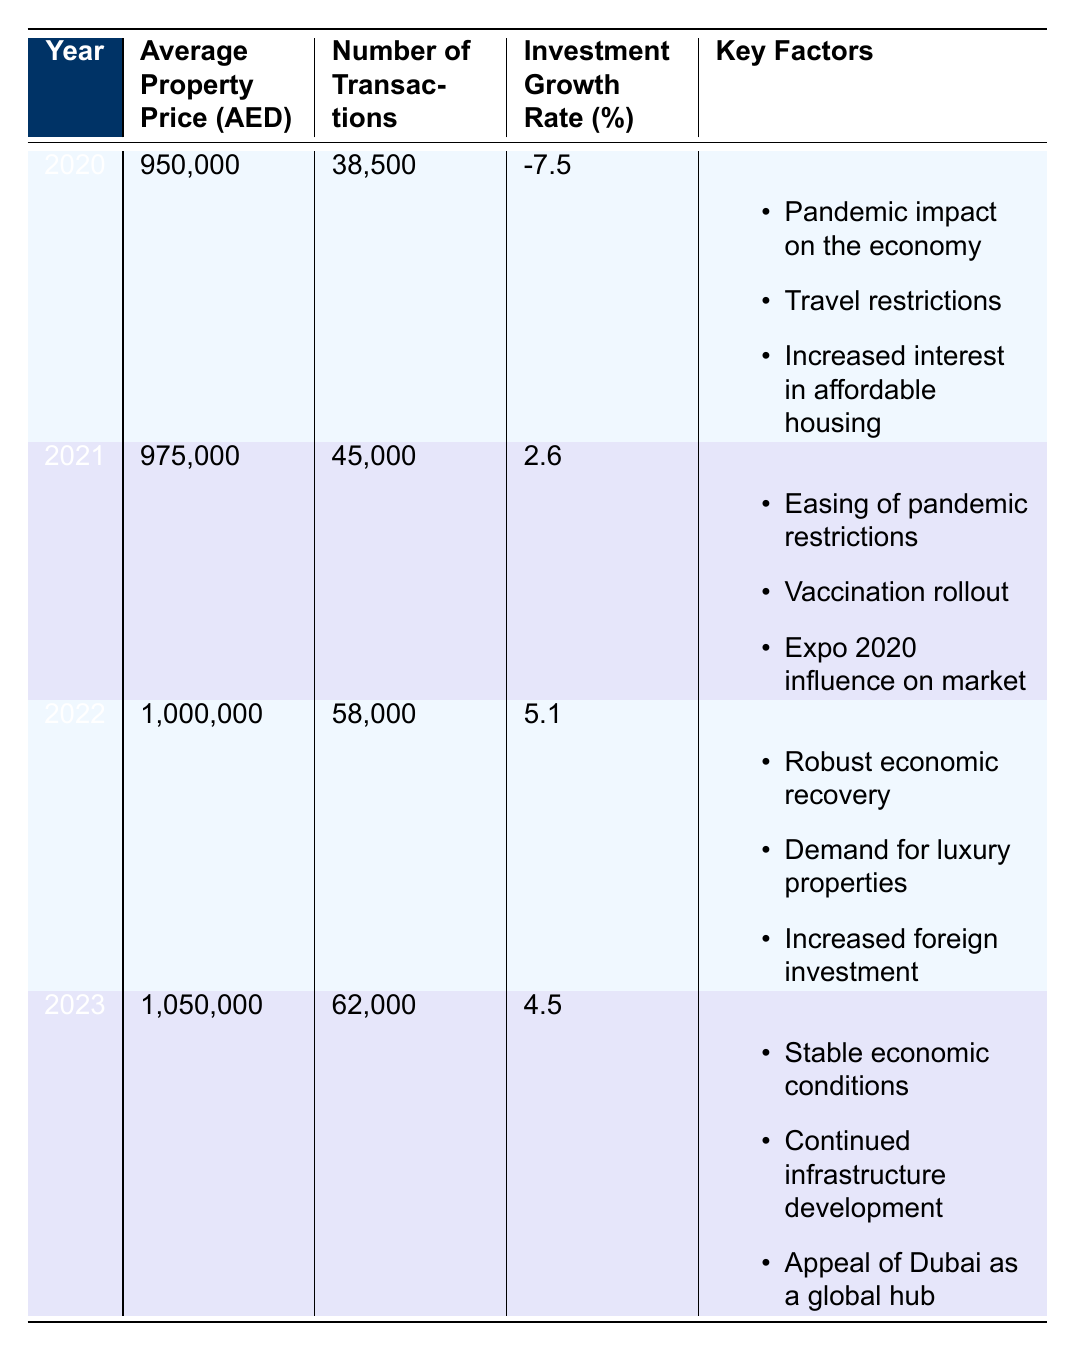What was the average property price in 2022? The table shows that the average property price for the year 2022 is listed in the corresponding row. The average property price for 2022 is 1,000,000 AED.
Answer: 1,000,000 AED In which year did the number of transactions exceed 60,000? By examining the number of transactions for each year in the table, we can see that the number of transactions was 62,000 in 2023, which exceeds 60,000.
Answer: 2023 What was the investment growth rate in 2021 compared to 2020? The growth rate in 2021 is 2.6% while in 2020 it was -7.5%. To find the difference, we subtract the 2020 rate from the 2021 rate: 2.6 - (-7.5) = 2.6 + 7.5 = 10.1. Therefore, the investment growth rate improved by 10.1 percentage points.
Answer: 10.1 percentage points Was there an increase in the average property price from 2020 to 2023? The average property price in 2020 was 950,000 AED, and in 2023 it was 1,050,000 AED. Since 1,050,000 AED is greater than 950,000 AED, it confirms that there was indeed an increase.
Answer: Yes What factors contributed to the investment growth in 2022? In the 2022 row, the key factors that contributed to the growth are listed as robust economic recovery, demand for luxury properties, and increased foreign investment. These factors collectively indicate why investment grew that year.
Answer: Robust economic recovery, demand for luxury properties, increased foreign investment Calculate the average investment growth rate over the four years. To find the average, we sum the growth rates for each year: (-7.5 + 2.6 + 5.1 + 4.5) = 4.7. There are four years, so we divide by 4: 4.7 / 4 = 1.175. The average investment growth rate across the four years is 1.175%.
Answer: 1.175% Did the number of transactions in 2022 exceed that in 2021? For 2022, there were 58,000 transactions and for 2021, there were 45,000 transactions. Since 58,000 is more than 45,000, the statement is true.
Answer: Yes Which year experienced the highest average property price increase compared to the previous year? By comparing the average property prices year-over-year: 2021 - 2020 = 975,000 - 950,000 = 25,000; 2022 - 2021 = 1,000,000 - 975,000 = 25,000; 2023 - 2022 = 1,050,000 - 1,000,000 = 50,000. The highest increase was from 2022 to 2023, which is 50,000 AED.
Answer: 2022 to 2023 What contributed to the decline in investment growth rate in 2020? The key factors that impacted the investment growth rate in 2020 are listed as pandemic impact on the economy, travel restrictions, and increased interest in affordable housing. Understanding these factors provides insights into the challenges of that year.
Answer: Pandemic impact on the economy, travel restrictions, increased interest in affordable housing 